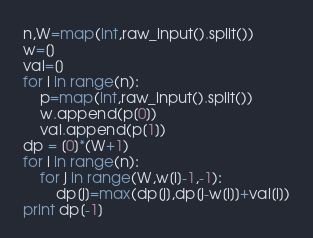Convert code to text. <code><loc_0><loc_0><loc_500><loc_500><_Python_>n,W=map(int,raw_input().split())
w=[]
val=[]
for i in range(n):
    p=map(int,raw_input().split())
    w.append(p[0])
    val.append(p[1])
dp = [0]*(W+1)
for i in range(n):
    for j in range(W,w[i]-1,-1):
        dp[j]=max(dp[j],dp[j-w[i]]+val[i])
print dp[-1]</code> 